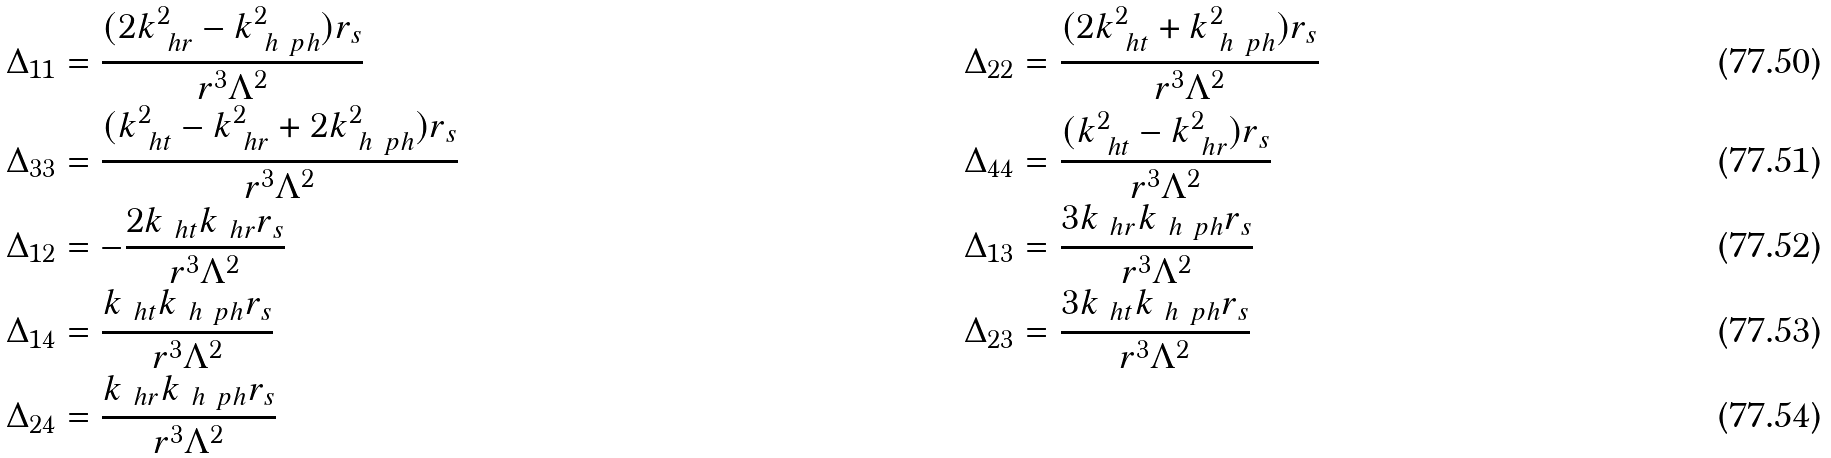<formula> <loc_0><loc_0><loc_500><loc_500>& \Delta _ { 1 1 } = \frac { ( 2 k _ { \ h { r } } ^ { 2 } - k _ { \ h { \ p h } } ^ { 2 } ) r _ { s } } { r ^ { 3 } \Lambda ^ { 2 } } & & \Delta _ { 2 2 } = \frac { ( 2 k _ { \ h { t } } ^ { 2 } + k _ { \ h { \ p h } } ^ { 2 } ) r _ { s } } { r ^ { 3 } \Lambda ^ { 2 } } \\ & \Delta _ { 3 3 } = \frac { ( k _ { \ h { t } } ^ { 2 } - k _ { \ h { r } } ^ { 2 } + 2 k _ { \ h { \ p h } } ^ { 2 } ) r _ { s } } { r ^ { 3 } \Lambda ^ { 2 } } & & \Delta _ { 4 4 } = \frac { ( k _ { \ h { t } } ^ { 2 } - k _ { \ h { r } } ^ { 2 } ) r _ { s } } { r ^ { 3 } \Lambda ^ { 2 } } \\ & \Delta _ { 1 2 } = - \frac { 2 k _ { \ h { t } } k _ { \ h { r } } r _ { s } } { r ^ { 3 } \Lambda ^ { 2 } } & & \Delta _ { 1 3 } = \frac { 3 k _ { \ h { r } } k _ { \ h { \ p h } } r _ { s } } { r ^ { 3 } \Lambda ^ { 2 } } \\ & \Delta _ { 1 4 } = \frac { k _ { \ h { t } } k _ { \ h { \ p h } } r _ { s } } { r ^ { 3 } \Lambda ^ { 2 } } & & \Delta _ { 2 3 } = \frac { 3 k _ { \ h { t } } k _ { \ h { \ p h } } r _ { s } } { r ^ { 3 } \Lambda ^ { 2 } } \\ & \Delta _ { 2 4 } = \frac { k _ { \ h { r } } k _ { \ h { \ p h } } r _ { s } } { r ^ { 3 } \Lambda ^ { 2 } }</formula> 